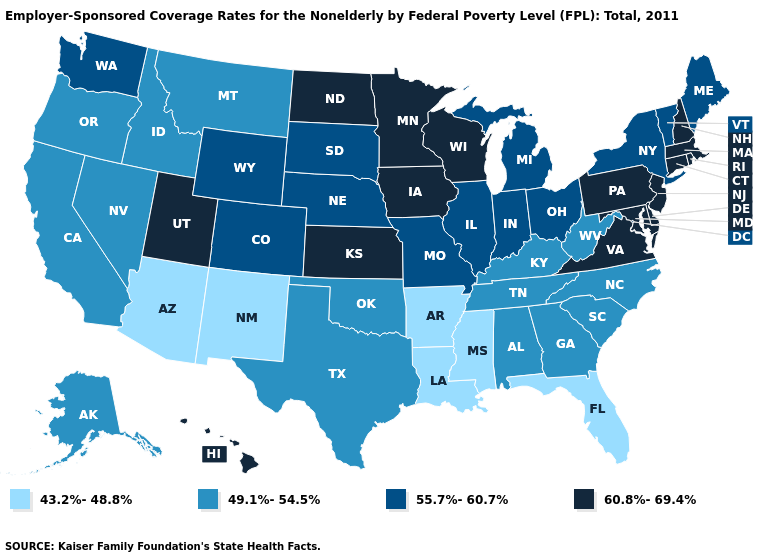What is the value of Wisconsin?
Quick response, please. 60.8%-69.4%. Which states have the lowest value in the MidWest?
Be succinct. Illinois, Indiana, Michigan, Missouri, Nebraska, Ohio, South Dakota. What is the value of Louisiana?
Short answer required. 43.2%-48.8%. What is the value of Rhode Island?
Give a very brief answer. 60.8%-69.4%. Name the states that have a value in the range 55.7%-60.7%?
Short answer required. Colorado, Illinois, Indiana, Maine, Michigan, Missouri, Nebraska, New York, Ohio, South Dakota, Vermont, Washington, Wyoming. What is the lowest value in the MidWest?
Be succinct. 55.7%-60.7%. Does Nevada have the lowest value in the West?
Be succinct. No. Which states have the lowest value in the USA?
Give a very brief answer. Arizona, Arkansas, Florida, Louisiana, Mississippi, New Mexico. What is the lowest value in the USA?
Give a very brief answer. 43.2%-48.8%. What is the lowest value in the MidWest?
Keep it brief. 55.7%-60.7%. What is the value of Wisconsin?
Be succinct. 60.8%-69.4%. Name the states that have a value in the range 43.2%-48.8%?
Write a very short answer. Arizona, Arkansas, Florida, Louisiana, Mississippi, New Mexico. Name the states that have a value in the range 49.1%-54.5%?
Keep it brief. Alabama, Alaska, California, Georgia, Idaho, Kentucky, Montana, Nevada, North Carolina, Oklahoma, Oregon, South Carolina, Tennessee, Texas, West Virginia. Name the states that have a value in the range 60.8%-69.4%?
Be succinct. Connecticut, Delaware, Hawaii, Iowa, Kansas, Maryland, Massachusetts, Minnesota, New Hampshire, New Jersey, North Dakota, Pennsylvania, Rhode Island, Utah, Virginia, Wisconsin. Which states have the highest value in the USA?
Be succinct. Connecticut, Delaware, Hawaii, Iowa, Kansas, Maryland, Massachusetts, Minnesota, New Hampshire, New Jersey, North Dakota, Pennsylvania, Rhode Island, Utah, Virginia, Wisconsin. 